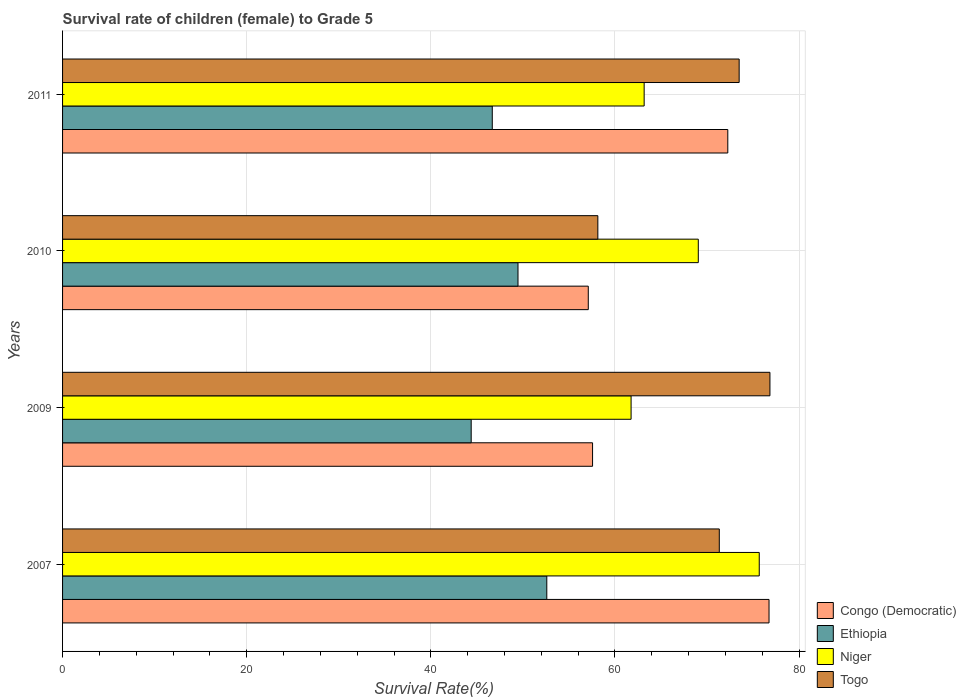How many different coloured bars are there?
Your answer should be compact. 4. How many groups of bars are there?
Give a very brief answer. 4. Are the number of bars per tick equal to the number of legend labels?
Your response must be concise. Yes. Are the number of bars on each tick of the Y-axis equal?
Provide a short and direct response. Yes. How many bars are there on the 3rd tick from the top?
Your response must be concise. 4. What is the label of the 4th group of bars from the top?
Your response must be concise. 2007. In how many cases, is the number of bars for a given year not equal to the number of legend labels?
Give a very brief answer. 0. What is the survival rate of female children to grade 5 in Congo (Democratic) in 2007?
Provide a succinct answer. 76.73. Across all years, what is the maximum survival rate of female children to grade 5 in Ethiopia?
Make the answer very short. 52.59. Across all years, what is the minimum survival rate of female children to grade 5 in Congo (Democratic)?
Offer a terse response. 57.1. What is the total survival rate of female children to grade 5 in Togo in the graph?
Offer a very short reply. 279.79. What is the difference between the survival rate of female children to grade 5 in Togo in 2010 and that in 2011?
Keep it short and to the point. -15.35. What is the difference between the survival rate of female children to grade 5 in Ethiopia in 2010 and the survival rate of female children to grade 5 in Togo in 2007?
Give a very brief answer. -21.86. What is the average survival rate of female children to grade 5 in Niger per year?
Your answer should be compact. 67.41. In the year 2010, what is the difference between the survival rate of female children to grade 5 in Congo (Democratic) and survival rate of female children to grade 5 in Niger?
Give a very brief answer. -11.95. In how many years, is the survival rate of female children to grade 5 in Congo (Democratic) greater than 24 %?
Provide a short and direct response. 4. What is the ratio of the survival rate of female children to grade 5 in Ethiopia in 2007 to that in 2009?
Offer a very short reply. 1.19. Is the difference between the survival rate of female children to grade 5 in Congo (Democratic) in 2007 and 2009 greater than the difference between the survival rate of female children to grade 5 in Niger in 2007 and 2009?
Offer a terse response. Yes. What is the difference between the highest and the second highest survival rate of female children to grade 5 in Ethiopia?
Your answer should be very brief. 3.13. What is the difference between the highest and the lowest survival rate of female children to grade 5 in Niger?
Offer a very short reply. 13.92. In how many years, is the survival rate of female children to grade 5 in Ethiopia greater than the average survival rate of female children to grade 5 in Ethiopia taken over all years?
Keep it short and to the point. 2. What does the 1st bar from the top in 2009 represents?
Provide a short and direct response. Togo. What does the 3rd bar from the bottom in 2011 represents?
Ensure brevity in your answer.  Niger. How many bars are there?
Offer a very short reply. 16. Are all the bars in the graph horizontal?
Your answer should be very brief. Yes. Are the values on the major ticks of X-axis written in scientific E-notation?
Ensure brevity in your answer.  No. Does the graph contain grids?
Ensure brevity in your answer.  Yes. How many legend labels are there?
Provide a succinct answer. 4. How are the legend labels stacked?
Your response must be concise. Vertical. What is the title of the graph?
Provide a short and direct response. Survival rate of children (female) to Grade 5. What is the label or title of the X-axis?
Your answer should be very brief. Survival Rate(%). What is the Survival Rate(%) of Congo (Democratic) in 2007?
Offer a very short reply. 76.73. What is the Survival Rate(%) in Ethiopia in 2007?
Your answer should be compact. 52.59. What is the Survival Rate(%) of Niger in 2007?
Your answer should be very brief. 75.67. What is the Survival Rate(%) of Togo in 2007?
Offer a terse response. 71.33. What is the Survival Rate(%) of Congo (Democratic) in 2009?
Keep it short and to the point. 57.57. What is the Survival Rate(%) of Ethiopia in 2009?
Your response must be concise. 44.38. What is the Survival Rate(%) in Niger in 2009?
Keep it short and to the point. 61.75. What is the Survival Rate(%) of Togo in 2009?
Ensure brevity in your answer.  76.83. What is the Survival Rate(%) of Congo (Democratic) in 2010?
Offer a terse response. 57.1. What is the Survival Rate(%) in Ethiopia in 2010?
Your response must be concise. 49.47. What is the Survival Rate(%) in Niger in 2010?
Offer a terse response. 69.05. What is the Survival Rate(%) in Togo in 2010?
Offer a very short reply. 58.14. What is the Survival Rate(%) of Congo (Democratic) in 2011?
Keep it short and to the point. 72.25. What is the Survival Rate(%) of Ethiopia in 2011?
Give a very brief answer. 46.67. What is the Survival Rate(%) in Niger in 2011?
Provide a succinct answer. 63.17. What is the Survival Rate(%) in Togo in 2011?
Offer a very short reply. 73.49. Across all years, what is the maximum Survival Rate(%) in Congo (Democratic)?
Provide a succinct answer. 76.73. Across all years, what is the maximum Survival Rate(%) of Ethiopia?
Your answer should be very brief. 52.59. Across all years, what is the maximum Survival Rate(%) in Niger?
Offer a terse response. 75.67. Across all years, what is the maximum Survival Rate(%) in Togo?
Give a very brief answer. 76.83. Across all years, what is the minimum Survival Rate(%) of Congo (Democratic)?
Offer a very short reply. 57.1. Across all years, what is the minimum Survival Rate(%) in Ethiopia?
Your response must be concise. 44.38. Across all years, what is the minimum Survival Rate(%) in Niger?
Make the answer very short. 61.75. Across all years, what is the minimum Survival Rate(%) of Togo?
Make the answer very short. 58.14. What is the total Survival Rate(%) of Congo (Democratic) in the graph?
Make the answer very short. 263.66. What is the total Survival Rate(%) in Ethiopia in the graph?
Your answer should be compact. 193.12. What is the total Survival Rate(%) of Niger in the graph?
Keep it short and to the point. 269.64. What is the total Survival Rate(%) in Togo in the graph?
Give a very brief answer. 279.79. What is the difference between the Survival Rate(%) of Congo (Democratic) in 2007 and that in 2009?
Give a very brief answer. 19.17. What is the difference between the Survival Rate(%) of Ethiopia in 2007 and that in 2009?
Give a very brief answer. 8.21. What is the difference between the Survival Rate(%) in Niger in 2007 and that in 2009?
Your answer should be very brief. 13.92. What is the difference between the Survival Rate(%) in Togo in 2007 and that in 2009?
Ensure brevity in your answer.  -5.5. What is the difference between the Survival Rate(%) in Congo (Democratic) in 2007 and that in 2010?
Your answer should be very brief. 19.63. What is the difference between the Survival Rate(%) of Ethiopia in 2007 and that in 2010?
Make the answer very short. 3.13. What is the difference between the Survival Rate(%) in Niger in 2007 and that in 2010?
Your answer should be compact. 6.62. What is the difference between the Survival Rate(%) in Togo in 2007 and that in 2010?
Keep it short and to the point. 13.19. What is the difference between the Survival Rate(%) in Congo (Democratic) in 2007 and that in 2011?
Provide a succinct answer. 4.48. What is the difference between the Survival Rate(%) in Ethiopia in 2007 and that in 2011?
Make the answer very short. 5.92. What is the difference between the Survival Rate(%) in Niger in 2007 and that in 2011?
Make the answer very short. 12.5. What is the difference between the Survival Rate(%) in Togo in 2007 and that in 2011?
Your response must be concise. -2.16. What is the difference between the Survival Rate(%) of Congo (Democratic) in 2009 and that in 2010?
Provide a short and direct response. 0.47. What is the difference between the Survival Rate(%) of Ethiopia in 2009 and that in 2010?
Provide a short and direct response. -5.08. What is the difference between the Survival Rate(%) in Niger in 2009 and that in 2010?
Your answer should be very brief. -7.3. What is the difference between the Survival Rate(%) of Togo in 2009 and that in 2010?
Offer a very short reply. 18.69. What is the difference between the Survival Rate(%) in Congo (Democratic) in 2009 and that in 2011?
Ensure brevity in your answer.  -14.69. What is the difference between the Survival Rate(%) of Ethiopia in 2009 and that in 2011?
Your answer should be compact. -2.29. What is the difference between the Survival Rate(%) of Niger in 2009 and that in 2011?
Your answer should be compact. -1.42. What is the difference between the Survival Rate(%) in Togo in 2009 and that in 2011?
Offer a very short reply. 3.34. What is the difference between the Survival Rate(%) of Congo (Democratic) in 2010 and that in 2011?
Your response must be concise. -15.15. What is the difference between the Survival Rate(%) in Ethiopia in 2010 and that in 2011?
Give a very brief answer. 2.79. What is the difference between the Survival Rate(%) in Niger in 2010 and that in 2011?
Your response must be concise. 5.88. What is the difference between the Survival Rate(%) of Togo in 2010 and that in 2011?
Your response must be concise. -15.35. What is the difference between the Survival Rate(%) in Congo (Democratic) in 2007 and the Survival Rate(%) in Ethiopia in 2009?
Your answer should be very brief. 32.35. What is the difference between the Survival Rate(%) of Congo (Democratic) in 2007 and the Survival Rate(%) of Niger in 2009?
Your answer should be compact. 14.98. What is the difference between the Survival Rate(%) of Congo (Democratic) in 2007 and the Survival Rate(%) of Togo in 2009?
Give a very brief answer. -0.1. What is the difference between the Survival Rate(%) in Ethiopia in 2007 and the Survival Rate(%) in Niger in 2009?
Your response must be concise. -9.16. What is the difference between the Survival Rate(%) in Ethiopia in 2007 and the Survival Rate(%) in Togo in 2009?
Provide a short and direct response. -24.24. What is the difference between the Survival Rate(%) in Niger in 2007 and the Survival Rate(%) in Togo in 2009?
Give a very brief answer. -1.16. What is the difference between the Survival Rate(%) in Congo (Democratic) in 2007 and the Survival Rate(%) in Ethiopia in 2010?
Your response must be concise. 27.27. What is the difference between the Survival Rate(%) in Congo (Democratic) in 2007 and the Survival Rate(%) in Niger in 2010?
Offer a very short reply. 7.68. What is the difference between the Survival Rate(%) of Congo (Democratic) in 2007 and the Survival Rate(%) of Togo in 2010?
Ensure brevity in your answer.  18.59. What is the difference between the Survival Rate(%) in Ethiopia in 2007 and the Survival Rate(%) in Niger in 2010?
Your response must be concise. -16.46. What is the difference between the Survival Rate(%) in Ethiopia in 2007 and the Survival Rate(%) in Togo in 2010?
Your answer should be very brief. -5.55. What is the difference between the Survival Rate(%) of Niger in 2007 and the Survival Rate(%) of Togo in 2010?
Provide a short and direct response. 17.53. What is the difference between the Survival Rate(%) of Congo (Democratic) in 2007 and the Survival Rate(%) of Ethiopia in 2011?
Provide a short and direct response. 30.06. What is the difference between the Survival Rate(%) in Congo (Democratic) in 2007 and the Survival Rate(%) in Niger in 2011?
Give a very brief answer. 13.56. What is the difference between the Survival Rate(%) in Congo (Democratic) in 2007 and the Survival Rate(%) in Togo in 2011?
Keep it short and to the point. 3.24. What is the difference between the Survival Rate(%) in Ethiopia in 2007 and the Survival Rate(%) in Niger in 2011?
Offer a very short reply. -10.58. What is the difference between the Survival Rate(%) of Ethiopia in 2007 and the Survival Rate(%) of Togo in 2011?
Your response must be concise. -20.89. What is the difference between the Survival Rate(%) of Niger in 2007 and the Survival Rate(%) of Togo in 2011?
Make the answer very short. 2.18. What is the difference between the Survival Rate(%) of Congo (Democratic) in 2009 and the Survival Rate(%) of Ethiopia in 2010?
Your answer should be very brief. 8.1. What is the difference between the Survival Rate(%) in Congo (Democratic) in 2009 and the Survival Rate(%) in Niger in 2010?
Give a very brief answer. -11.48. What is the difference between the Survival Rate(%) of Congo (Democratic) in 2009 and the Survival Rate(%) of Togo in 2010?
Provide a succinct answer. -0.57. What is the difference between the Survival Rate(%) of Ethiopia in 2009 and the Survival Rate(%) of Niger in 2010?
Ensure brevity in your answer.  -24.67. What is the difference between the Survival Rate(%) of Ethiopia in 2009 and the Survival Rate(%) of Togo in 2010?
Keep it short and to the point. -13.76. What is the difference between the Survival Rate(%) in Niger in 2009 and the Survival Rate(%) in Togo in 2010?
Give a very brief answer. 3.61. What is the difference between the Survival Rate(%) of Congo (Democratic) in 2009 and the Survival Rate(%) of Ethiopia in 2011?
Keep it short and to the point. 10.89. What is the difference between the Survival Rate(%) of Congo (Democratic) in 2009 and the Survival Rate(%) of Niger in 2011?
Your answer should be compact. -5.6. What is the difference between the Survival Rate(%) in Congo (Democratic) in 2009 and the Survival Rate(%) in Togo in 2011?
Ensure brevity in your answer.  -15.92. What is the difference between the Survival Rate(%) of Ethiopia in 2009 and the Survival Rate(%) of Niger in 2011?
Ensure brevity in your answer.  -18.79. What is the difference between the Survival Rate(%) of Ethiopia in 2009 and the Survival Rate(%) of Togo in 2011?
Your answer should be very brief. -29.11. What is the difference between the Survival Rate(%) in Niger in 2009 and the Survival Rate(%) in Togo in 2011?
Your answer should be compact. -11.74. What is the difference between the Survival Rate(%) of Congo (Democratic) in 2010 and the Survival Rate(%) of Ethiopia in 2011?
Ensure brevity in your answer.  10.43. What is the difference between the Survival Rate(%) in Congo (Democratic) in 2010 and the Survival Rate(%) in Niger in 2011?
Provide a short and direct response. -6.07. What is the difference between the Survival Rate(%) of Congo (Democratic) in 2010 and the Survival Rate(%) of Togo in 2011?
Provide a short and direct response. -16.39. What is the difference between the Survival Rate(%) in Ethiopia in 2010 and the Survival Rate(%) in Niger in 2011?
Make the answer very short. -13.7. What is the difference between the Survival Rate(%) in Ethiopia in 2010 and the Survival Rate(%) in Togo in 2011?
Offer a very short reply. -24.02. What is the difference between the Survival Rate(%) in Niger in 2010 and the Survival Rate(%) in Togo in 2011?
Provide a short and direct response. -4.44. What is the average Survival Rate(%) of Congo (Democratic) per year?
Provide a short and direct response. 65.91. What is the average Survival Rate(%) in Ethiopia per year?
Offer a terse response. 48.28. What is the average Survival Rate(%) of Niger per year?
Offer a very short reply. 67.41. What is the average Survival Rate(%) in Togo per year?
Make the answer very short. 69.95. In the year 2007, what is the difference between the Survival Rate(%) of Congo (Democratic) and Survival Rate(%) of Ethiopia?
Offer a terse response. 24.14. In the year 2007, what is the difference between the Survival Rate(%) in Congo (Democratic) and Survival Rate(%) in Niger?
Offer a terse response. 1.06. In the year 2007, what is the difference between the Survival Rate(%) in Congo (Democratic) and Survival Rate(%) in Togo?
Your response must be concise. 5.4. In the year 2007, what is the difference between the Survival Rate(%) in Ethiopia and Survival Rate(%) in Niger?
Your response must be concise. -23.08. In the year 2007, what is the difference between the Survival Rate(%) of Ethiopia and Survival Rate(%) of Togo?
Offer a very short reply. -18.74. In the year 2007, what is the difference between the Survival Rate(%) in Niger and Survival Rate(%) in Togo?
Your answer should be compact. 4.34. In the year 2009, what is the difference between the Survival Rate(%) of Congo (Democratic) and Survival Rate(%) of Ethiopia?
Make the answer very short. 13.18. In the year 2009, what is the difference between the Survival Rate(%) of Congo (Democratic) and Survival Rate(%) of Niger?
Ensure brevity in your answer.  -4.18. In the year 2009, what is the difference between the Survival Rate(%) of Congo (Democratic) and Survival Rate(%) of Togo?
Your answer should be compact. -19.27. In the year 2009, what is the difference between the Survival Rate(%) in Ethiopia and Survival Rate(%) in Niger?
Offer a very short reply. -17.37. In the year 2009, what is the difference between the Survival Rate(%) of Ethiopia and Survival Rate(%) of Togo?
Your answer should be very brief. -32.45. In the year 2009, what is the difference between the Survival Rate(%) in Niger and Survival Rate(%) in Togo?
Your answer should be compact. -15.08. In the year 2010, what is the difference between the Survival Rate(%) of Congo (Democratic) and Survival Rate(%) of Ethiopia?
Your response must be concise. 7.63. In the year 2010, what is the difference between the Survival Rate(%) in Congo (Democratic) and Survival Rate(%) in Niger?
Your response must be concise. -11.95. In the year 2010, what is the difference between the Survival Rate(%) in Congo (Democratic) and Survival Rate(%) in Togo?
Ensure brevity in your answer.  -1.04. In the year 2010, what is the difference between the Survival Rate(%) of Ethiopia and Survival Rate(%) of Niger?
Give a very brief answer. -19.58. In the year 2010, what is the difference between the Survival Rate(%) of Ethiopia and Survival Rate(%) of Togo?
Provide a succinct answer. -8.67. In the year 2010, what is the difference between the Survival Rate(%) of Niger and Survival Rate(%) of Togo?
Make the answer very short. 10.91. In the year 2011, what is the difference between the Survival Rate(%) of Congo (Democratic) and Survival Rate(%) of Ethiopia?
Your answer should be compact. 25.58. In the year 2011, what is the difference between the Survival Rate(%) of Congo (Democratic) and Survival Rate(%) of Niger?
Provide a succinct answer. 9.08. In the year 2011, what is the difference between the Survival Rate(%) of Congo (Democratic) and Survival Rate(%) of Togo?
Give a very brief answer. -1.23. In the year 2011, what is the difference between the Survival Rate(%) of Ethiopia and Survival Rate(%) of Niger?
Keep it short and to the point. -16.5. In the year 2011, what is the difference between the Survival Rate(%) of Ethiopia and Survival Rate(%) of Togo?
Provide a succinct answer. -26.81. In the year 2011, what is the difference between the Survival Rate(%) in Niger and Survival Rate(%) in Togo?
Provide a succinct answer. -10.32. What is the ratio of the Survival Rate(%) in Congo (Democratic) in 2007 to that in 2009?
Ensure brevity in your answer.  1.33. What is the ratio of the Survival Rate(%) in Ethiopia in 2007 to that in 2009?
Your response must be concise. 1.19. What is the ratio of the Survival Rate(%) of Niger in 2007 to that in 2009?
Your answer should be very brief. 1.23. What is the ratio of the Survival Rate(%) of Togo in 2007 to that in 2009?
Provide a short and direct response. 0.93. What is the ratio of the Survival Rate(%) of Congo (Democratic) in 2007 to that in 2010?
Provide a succinct answer. 1.34. What is the ratio of the Survival Rate(%) of Ethiopia in 2007 to that in 2010?
Your answer should be compact. 1.06. What is the ratio of the Survival Rate(%) of Niger in 2007 to that in 2010?
Give a very brief answer. 1.1. What is the ratio of the Survival Rate(%) of Togo in 2007 to that in 2010?
Your answer should be compact. 1.23. What is the ratio of the Survival Rate(%) in Congo (Democratic) in 2007 to that in 2011?
Your answer should be compact. 1.06. What is the ratio of the Survival Rate(%) in Ethiopia in 2007 to that in 2011?
Make the answer very short. 1.13. What is the ratio of the Survival Rate(%) of Niger in 2007 to that in 2011?
Offer a very short reply. 1.2. What is the ratio of the Survival Rate(%) in Togo in 2007 to that in 2011?
Provide a succinct answer. 0.97. What is the ratio of the Survival Rate(%) of Congo (Democratic) in 2009 to that in 2010?
Your answer should be very brief. 1.01. What is the ratio of the Survival Rate(%) of Ethiopia in 2009 to that in 2010?
Offer a very short reply. 0.9. What is the ratio of the Survival Rate(%) of Niger in 2009 to that in 2010?
Offer a very short reply. 0.89. What is the ratio of the Survival Rate(%) of Togo in 2009 to that in 2010?
Provide a succinct answer. 1.32. What is the ratio of the Survival Rate(%) in Congo (Democratic) in 2009 to that in 2011?
Your answer should be very brief. 0.8. What is the ratio of the Survival Rate(%) of Ethiopia in 2009 to that in 2011?
Keep it short and to the point. 0.95. What is the ratio of the Survival Rate(%) of Niger in 2009 to that in 2011?
Your answer should be very brief. 0.98. What is the ratio of the Survival Rate(%) in Togo in 2009 to that in 2011?
Offer a terse response. 1.05. What is the ratio of the Survival Rate(%) in Congo (Democratic) in 2010 to that in 2011?
Your response must be concise. 0.79. What is the ratio of the Survival Rate(%) in Ethiopia in 2010 to that in 2011?
Your answer should be very brief. 1.06. What is the ratio of the Survival Rate(%) in Niger in 2010 to that in 2011?
Offer a very short reply. 1.09. What is the ratio of the Survival Rate(%) in Togo in 2010 to that in 2011?
Provide a short and direct response. 0.79. What is the difference between the highest and the second highest Survival Rate(%) in Congo (Democratic)?
Provide a succinct answer. 4.48. What is the difference between the highest and the second highest Survival Rate(%) in Ethiopia?
Ensure brevity in your answer.  3.13. What is the difference between the highest and the second highest Survival Rate(%) in Niger?
Ensure brevity in your answer.  6.62. What is the difference between the highest and the second highest Survival Rate(%) of Togo?
Your answer should be very brief. 3.34. What is the difference between the highest and the lowest Survival Rate(%) in Congo (Democratic)?
Give a very brief answer. 19.63. What is the difference between the highest and the lowest Survival Rate(%) in Ethiopia?
Give a very brief answer. 8.21. What is the difference between the highest and the lowest Survival Rate(%) of Niger?
Your response must be concise. 13.92. What is the difference between the highest and the lowest Survival Rate(%) of Togo?
Make the answer very short. 18.69. 